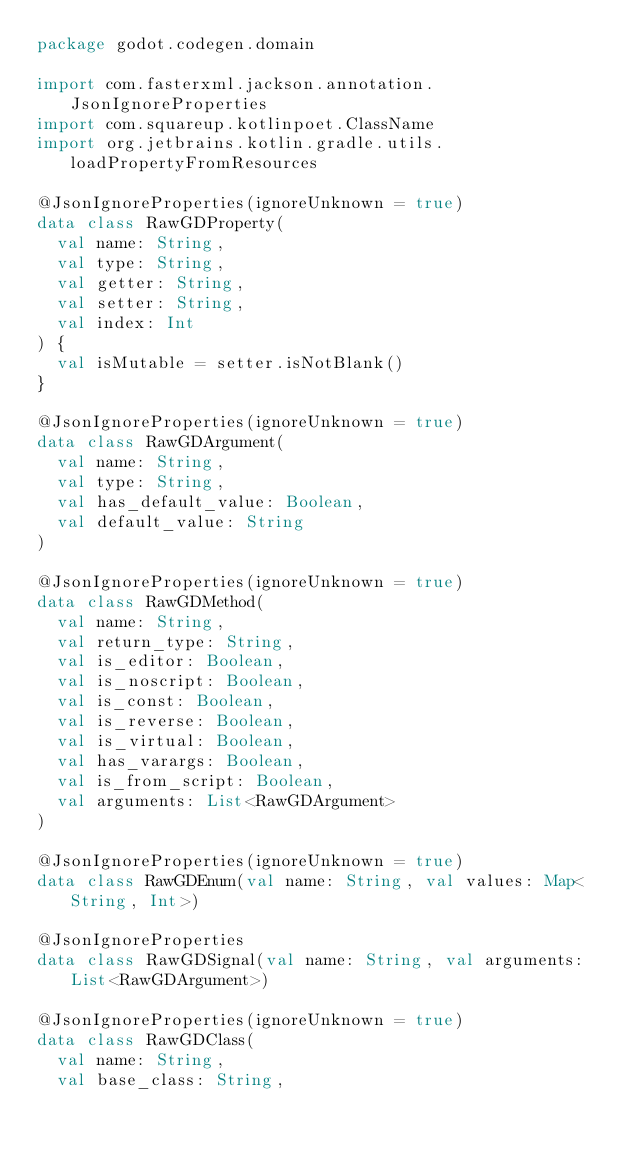Convert code to text. <code><loc_0><loc_0><loc_500><loc_500><_Kotlin_>package godot.codegen.domain

import com.fasterxml.jackson.annotation.JsonIgnoreProperties
import com.squareup.kotlinpoet.ClassName
import org.jetbrains.kotlin.gradle.utils.loadPropertyFromResources

@JsonIgnoreProperties(ignoreUnknown = true)
data class RawGDProperty(
  val name: String,
  val type: String,
  val getter: String,
  val setter: String,
  val index: Int
) {
  val isMutable = setter.isNotBlank()
}

@JsonIgnoreProperties(ignoreUnknown = true)
data class RawGDArgument(
  val name: String,
  val type: String,
  val has_default_value: Boolean,
  val default_value: String
)

@JsonIgnoreProperties(ignoreUnknown = true)
data class RawGDMethod(
  val name: String,
  val return_type: String,
  val is_editor: Boolean,
  val is_noscript: Boolean,
  val is_const: Boolean,
  val is_reverse: Boolean,
  val is_virtual: Boolean,
  val has_varargs: Boolean,
  val is_from_script: Boolean,
  val arguments: List<RawGDArgument>
)

@JsonIgnoreProperties(ignoreUnknown = true)
data class RawGDEnum(val name: String, val values: Map<String, Int>)

@JsonIgnoreProperties
data class RawGDSignal(val name: String, val arguments: List<RawGDArgument>)

@JsonIgnoreProperties(ignoreUnknown = true)
data class RawGDClass(
  val name: String,
  val base_class: String,</code> 